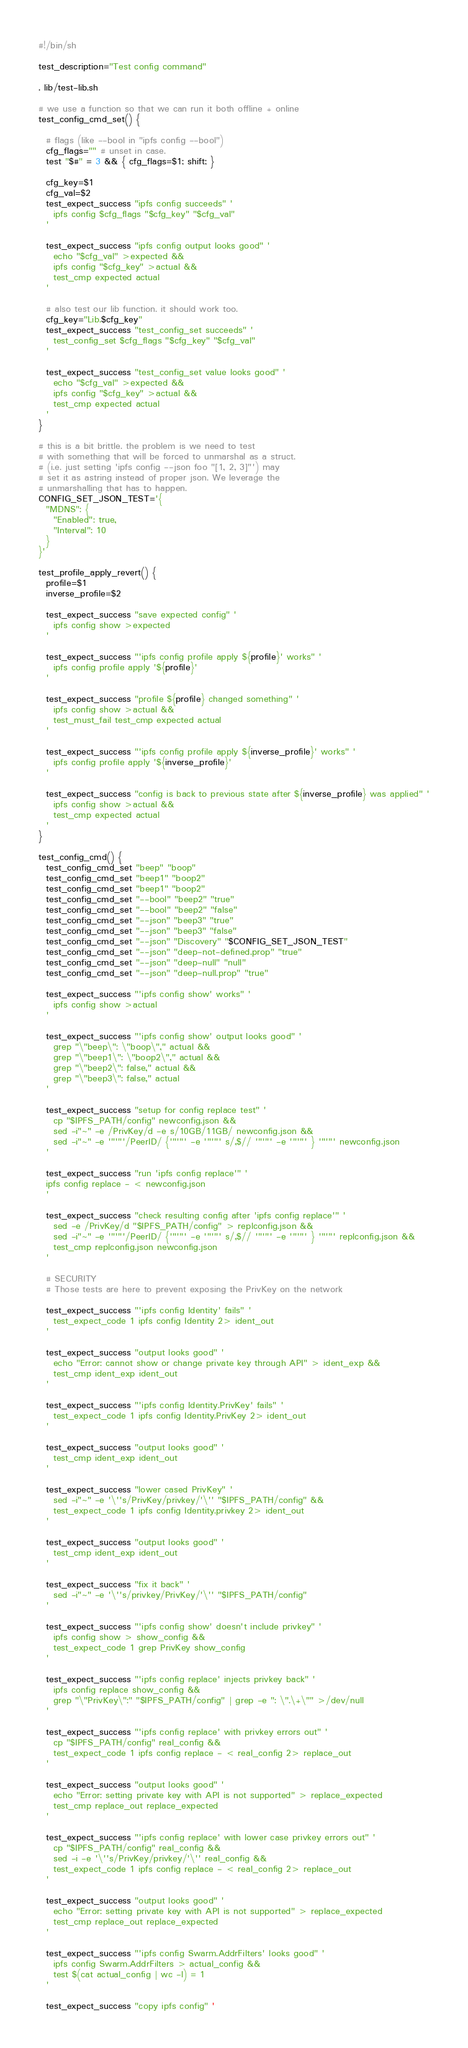Convert code to text. <code><loc_0><loc_0><loc_500><loc_500><_Bash_>#!/bin/sh

test_description="Test config command"

. lib/test-lib.sh

# we use a function so that we can run it both offline + online
test_config_cmd_set() {

  # flags (like --bool in "ipfs config --bool")
  cfg_flags="" # unset in case.
  test "$#" = 3 && { cfg_flags=$1; shift; }

  cfg_key=$1
  cfg_val=$2
  test_expect_success "ipfs config succeeds" '
    ipfs config $cfg_flags "$cfg_key" "$cfg_val"
  '

  test_expect_success "ipfs config output looks good" '
    echo "$cfg_val" >expected &&
    ipfs config "$cfg_key" >actual &&
    test_cmp expected actual
  '

  # also test our lib function. it should work too.
  cfg_key="Lib.$cfg_key"
  test_expect_success "test_config_set succeeds" '
    test_config_set $cfg_flags "$cfg_key" "$cfg_val"
  '

  test_expect_success "test_config_set value looks good" '
    echo "$cfg_val" >expected &&
    ipfs config "$cfg_key" >actual &&
    test_cmp expected actual
  '
}

# this is a bit brittle. the problem is we need to test
# with something that will be forced to unmarshal as a struct.
# (i.e. just setting 'ipfs config --json foo "[1, 2, 3]"') may
# set it as astring instead of proper json. We leverage the
# unmarshalling that has to happen.
CONFIG_SET_JSON_TEST='{
  "MDNS": {
    "Enabled": true,
    "Interval": 10
  }
}'

test_profile_apply_revert() {
  profile=$1
  inverse_profile=$2

  test_expect_success "save expected config" '
    ipfs config show >expected
  '

  test_expect_success "'ipfs config profile apply ${profile}' works" '
    ipfs config profile apply '${profile}'
  '

  test_expect_success "profile ${profile} changed something" '
    ipfs config show >actual &&
    test_must_fail test_cmp expected actual
  '

  test_expect_success "'ipfs config profile apply ${inverse_profile}' works" '
    ipfs config profile apply '${inverse_profile}'
  '

  test_expect_success "config is back to previous state after ${inverse_profile} was applied" '
    ipfs config show >actual &&
    test_cmp expected actual
  '
}

test_config_cmd() {
  test_config_cmd_set "beep" "boop"
  test_config_cmd_set "beep1" "boop2"
  test_config_cmd_set "beep1" "boop2"
  test_config_cmd_set "--bool" "beep2" "true"
  test_config_cmd_set "--bool" "beep2" "false"
  test_config_cmd_set "--json" "beep3" "true"
  test_config_cmd_set "--json" "beep3" "false"
  test_config_cmd_set "--json" "Discovery" "$CONFIG_SET_JSON_TEST"
  test_config_cmd_set "--json" "deep-not-defined.prop" "true"
  test_config_cmd_set "--json" "deep-null" "null"
  test_config_cmd_set "--json" "deep-null.prop" "true"

  test_expect_success "'ipfs config show' works" '
    ipfs config show >actual
  '

  test_expect_success "'ipfs config show' output looks good" '
    grep "\"beep\": \"boop\"," actual &&
    grep "\"beep1\": \"boop2\"," actual &&
    grep "\"beep2\": false," actual &&
    grep "\"beep3\": false," actual
  '

  test_expect_success "setup for config replace test" '
    cp "$IPFS_PATH/config" newconfig.json &&
    sed -i"~" -e /PrivKey/d -e s/10GB/11GB/ newconfig.json &&
    sed -i"~" -e '"'"'/PeerID/ {'"'"' -e '"'"' s/,$// '"'"' -e '"'"' } '"'"' newconfig.json
  '

  test_expect_success "run 'ipfs config replace'" '
  ipfs config replace - < newconfig.json
  '

  test_expect_success "check resulting config after 'ipfs config replace'" '
    sed -e /PrivKey/d "$IPFS_PATH/config" > replconfig.json &&
    sed -i"~" -e '"'"'/PeerID/ {'"'"' -e '"'"' s/,$// '"'"' -e '"'"' } '"'"' replconfig.json &&
    test_cmp replconfig.json newconfig.json
  '

  # SECURITY
  # Those tests are here to prevent exposing the PrivKey on the network

  test_expect_success "'ipfs config Identity' fails" '
    test_expect_code 1 ipfs config Identity 2> ident_out
  '

  test_expect_success "output looks good" '
    echo "Error: cannot show or change private key through API" > ident_exp &&
    test_cmp ident_exp ident_out
  '

  test_expect_success "'ipfs config Identity.PrivKey' fails" '
    test_expect_code 1 ipfs config Identity.PrivKey 2> ident_out
  '

  test_expect_success "output looks good" '
    test_cmp ident_exp ident_out
  '

  test_expect_success "lower cased PrivKey" '
    sed -i"~" -e '\''s/PrivKey/privkey/'\'' "$IPFS_PATH/config" &&
    test_expect_code 1 ipfs config Identity.privkey 2> ident_out
  '

  test_expect_success "output looks good" '
    test_cmp ident_exp ident_out
  '

  test_expect_success "fix it back" '
    sed -i"~" -e '\''s/privkey/PrivKey/'\'' "$IPFS_PATH/config"
  '

  test_expect_success "'ipfs config show' doesn't include privkey" '
    ipfs config show > show_config &&
    test_expect_code 1 grep PrivKey show_config
  '

  test_expect_success "'ipfs config replace' injects privkey back" '
    ipfs config replace show_config &&
    grep "\"PrivKey\":" "$IPFS_PATH/config" | grep -e ": \".\+\"" >/dev/null
  '

  test_expect_success "'ipfs config replace' with privkey errors out" '
    cp "$IPFS_PATH/config" real_config &&
    test_expect_code 1 ipfs config replace - < real_config 2> replace_out
  '

  test_expect_success "output looks good" '
    echo "Error: setting private key with API is not supported" > replace_expected
    test_cmp replace_out replace_expected
  '

  test_expect_success "'ipfs config replace' with lower case privkey errors out" '
    cp "$IPFS_PATH/config" real_config &&
    sed -i -e '\''s/PrivKey/privkey/'\'' real_config &&
    test_expect_code 1 ipfs config replace - < real_config 2> replace_out
  '

  test_expect_success "output looks good" '
    echo "Error: setting private key with API is not supported" > replace_expected
    test_cmp replace_out replace_expected
  '

  test_expect_success "'ipfs config Swarm.AddrFilters' looks good" '
    ipfs config Swarm.AddrFilters > actual_config &&
    test $(cat actual_config | wc -l) = 1
  '

  test_expect_success "copy ipfs config" '</code> 